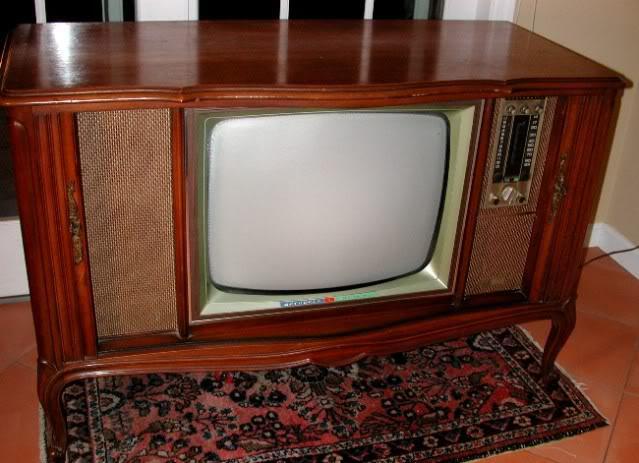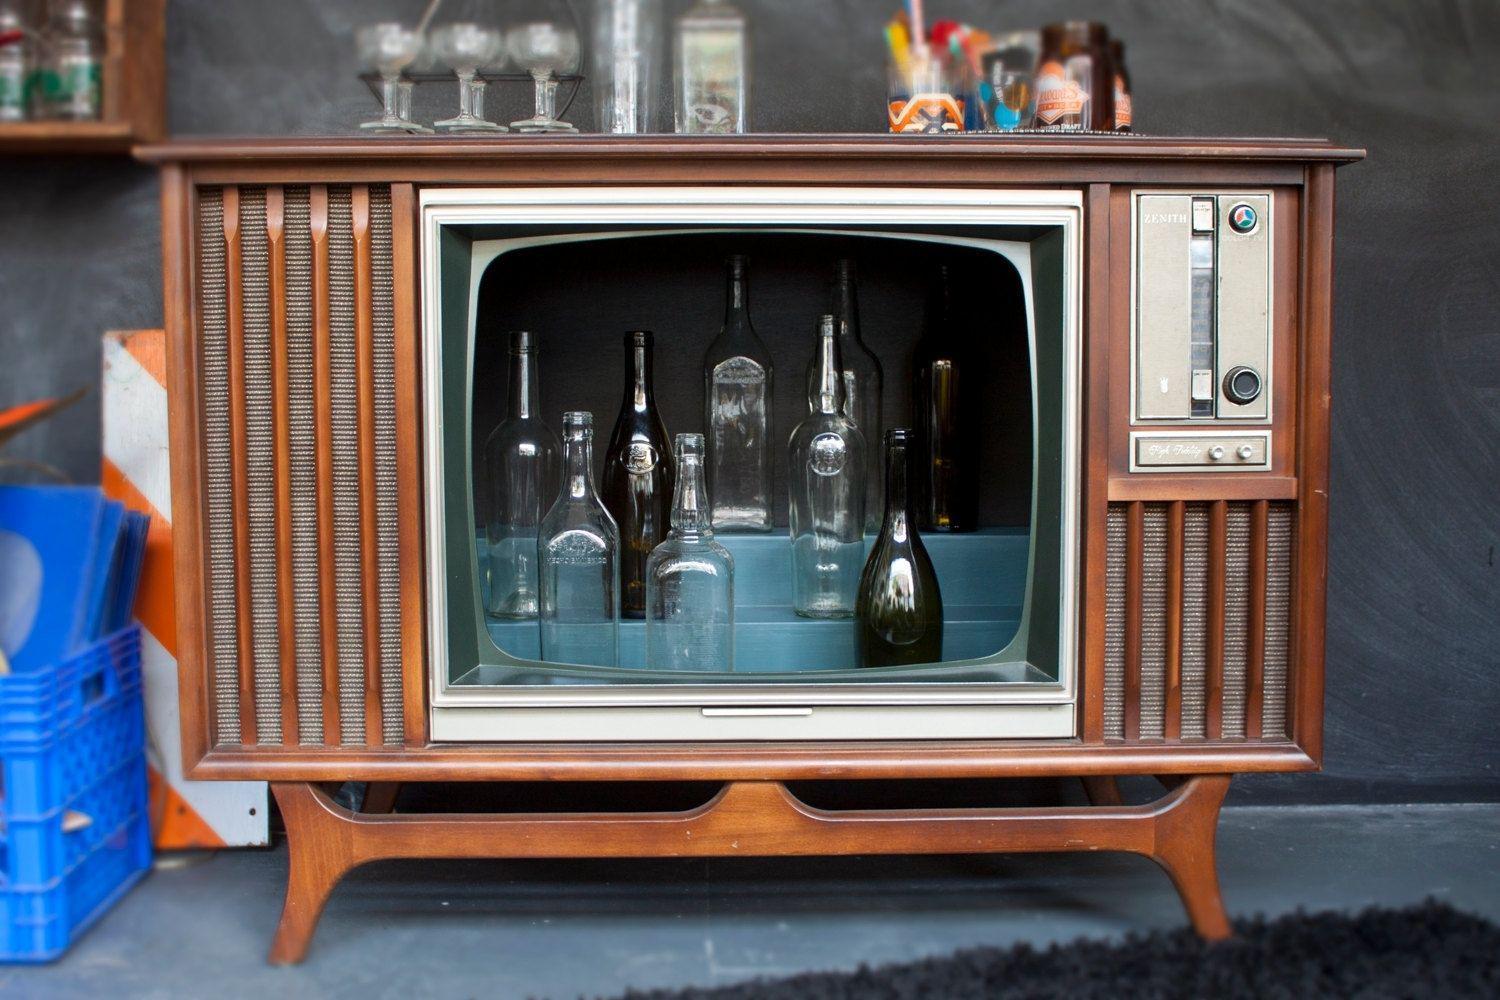The first image is the image on the left, the second image is the image on the right. Assess this claim about the two images: "There are two tvs, and one of them has had its screen removed.". Correct or not? Answer yes or no. Yes. The first image is the image on the left, the second image is the image on the right. Evaluate the accuracy of this statement regarding the images: "At least one animal is inside a hollowed out antique television set.". Is it true? Answer yes or no. No. 